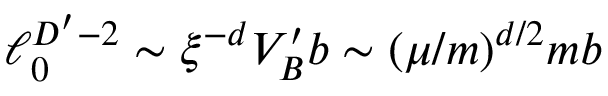Convert formula to latex. <formula><loc_0><loc_0><loc_500><loc_500>\ell _ { 0 } ^ { D ^ { \prime } - 2 } \sim \xi ^ { - d } V _ { B } ^ { \prime } b \sim ( \mu / m ) ^ { d / 2 } m b</formula> 